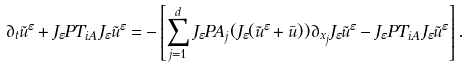Convert formula to latex. <formula><loc_0><loc_0><loc_500><loc_500>\partial _ { t } \tilde { u } ^ { \varepsilon } + J _ { \varepsilon } P T _ { i A } J _ { \varepsilon } \tilde { u } ^ { \varepsilon } = - \left [ \sum _ { j = 1 } ^ { d } J _ { \varepsilon } P A _ { j } ( J _ { \varepsilon } ( \tilde { u } ^ { \varepsilon } + \bar { u } ) ) \partial _ { x _ { j } } J _ { \varepsilon } \tilde { u } ^ { \varepsilon } - J _ { \varepsilon } P T _ { i A } J _ { \varepsilon } \tilde { u } ^ { \varepsilon } \right ] .</formula> 